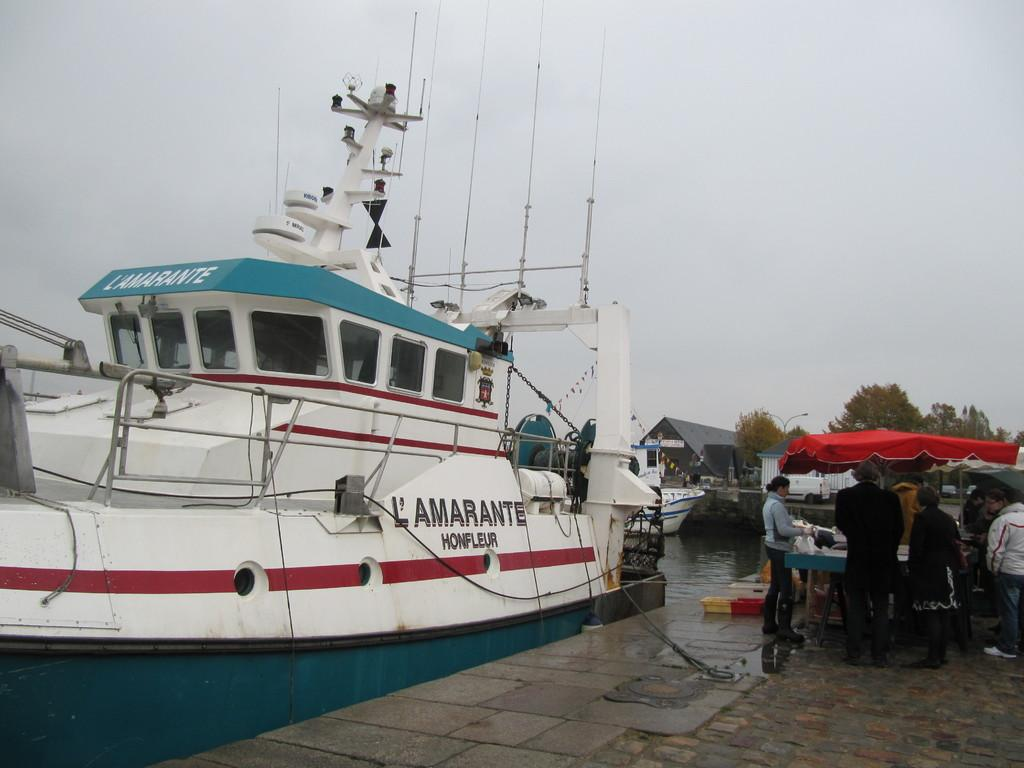What type of vehicle is in the image? There is a white ship in the image. Where are the people located in relation to the ship? The people are standing on the right side of the ship. How would you describe the weather based on the image? The sky is cloudy in the image. What flavor of ant can be seen crawling on the ship in the image? There are no ants present in the image, and therefore no flavor can be determined. 